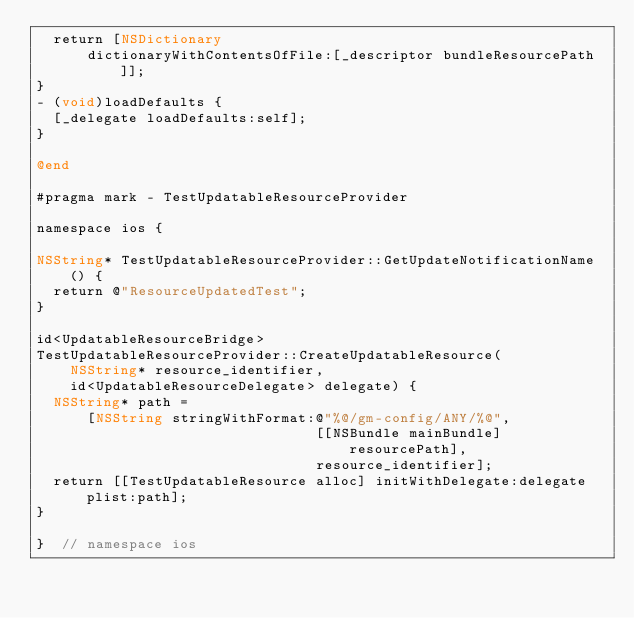Convert code to text. <code><loc_0><loc_0><loc_500><loc_500><_ObjectiveC_>  return [NSDictionary
      dictionaryWithContentsOfFile:[_descriptor bundleResourcePath]];
}
- (void)loadDefaults {
  [_delegate loadDefaults:self];
}

@end

#pragma mark - TestUpdatableResourceProvider

namespace ios {

NSString* TestUpdatableResourceProvider::GetUpdateNotificationName() {
  return @"ResourceUpdatedTest";
}

id<UpdatableResourceBridge>
TestUpdatableResourceProvider::CreateUpdatableResource(
    NSString* resource_identifier,
    id<UpdatableResourceDelegate> delegate) {
  NSString* path =
      [NSString stringWithFormat:@"%@/gm-config/ANY/%@",
                                 [[NSBundle mainBundle] resourcePath],
                                 resource_identifier];
  return [[TestUpdatableResource alloc] initWithDelegate:delegate plist:path];
}

}  // namespace ios
</code> 